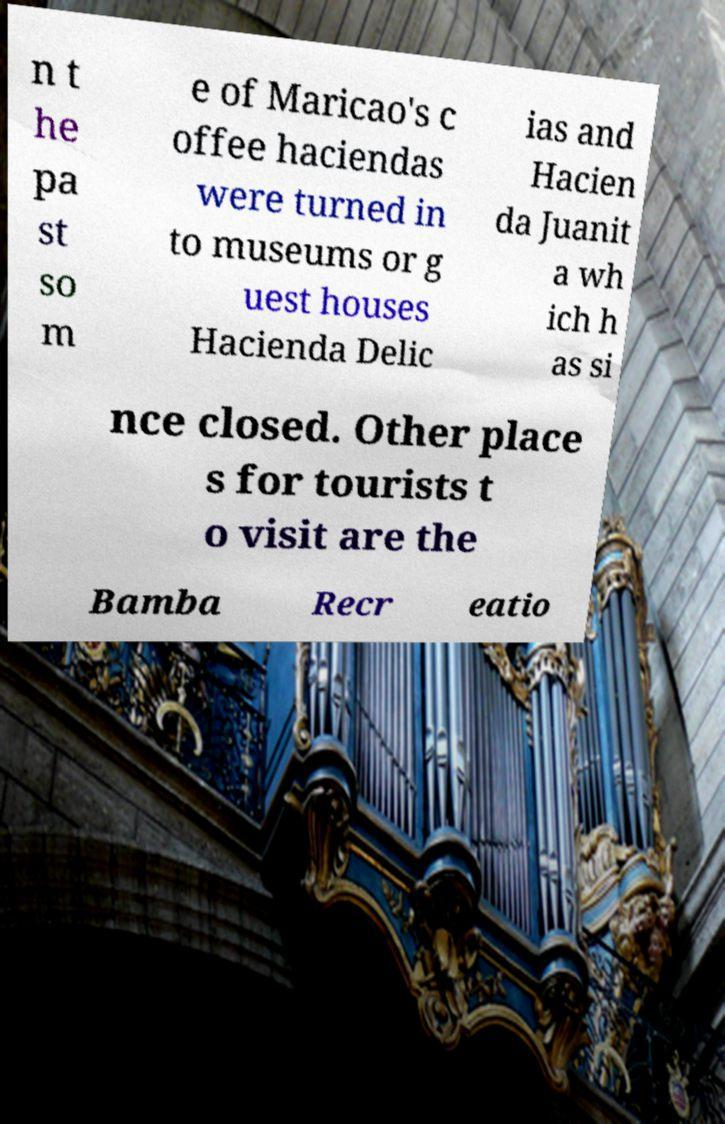Can you accurately transcribe the text from the provided image for me? n t he pa st so m e of Maricao's c offee haciendas were turned in to museums or g uest houses Hacienda Delic ias and Hacien da Juanit a wh ich h as si nce closed. Other place s for tourists t o visit are the Bamba Recr eatio 